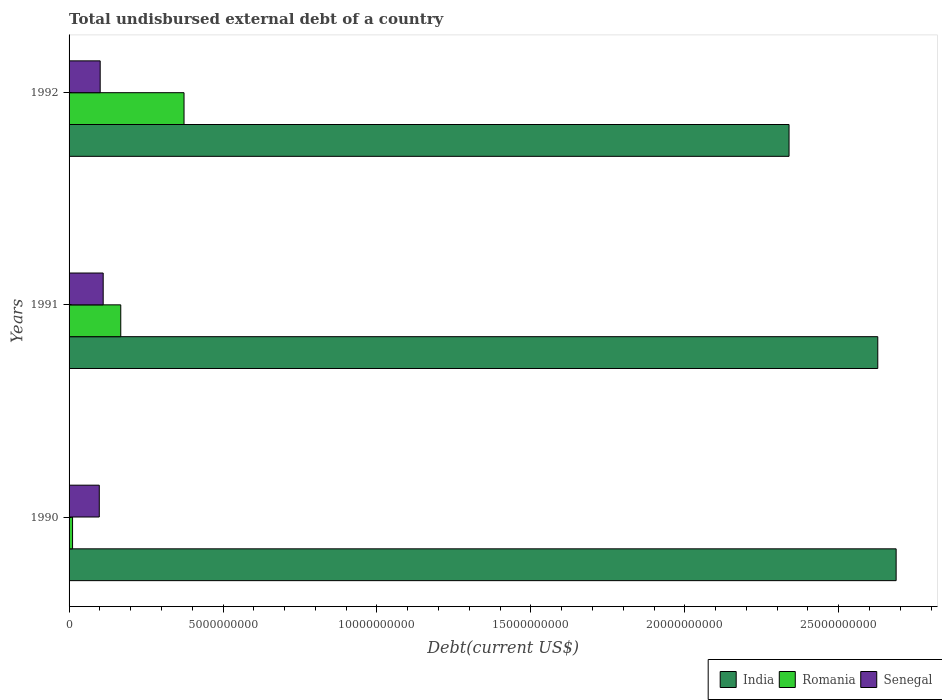How many different coloured bars are there?
Your response must be concise. 3. How many groups of bars are there?
Provide a succinct answer. 3. Are the number of bars per tick equal to the number of legend labels?
Your answer should be very brief. Yes. Are the number of bars on each tick of the Y-axis equal?
Provide a succinct answer. Yes. How many bars are there on the 3rd tick from the top?
Your response must be concise. 3. What is the label of the 3rd group of bars from the top?
Ensure brevity in your answer.  1990. What is the total undisbursed external debt in Romania in 1991?
Your answer should be very brief. 1.68e+09. Across all years, what is the maximum total undisbursed external debt in India?
Keep it short and to the point. 2.69e+1. Across all years, what is the minimum total undisbursed external debt in Romania?
Provide a short and direct response. 1.13e+08. In which year was the total undisbursed external debt in Romania maximum?
Give a very brief answer. 1992. In which year was the total undisbursed external debt in Senegal minimum?
Ensure brevity in your answer.  1990. What is the total total undisbursed external debt in Senegal in the graph?
Offer a terse response. 3.10e+09. What is the difference between the total undisbursed external debt in Romania in 1990 and that in 1991?
Offer a terse response. -1.57e+09. What is the difference between the total undisbursed external debt in Romania in 1990 and the total undisbursed external debt in Senegal in 1992?
Your answer should be very brief. -8.97e+08. What is the average total undisbursed external debt in Senegal per year?
Give a very brief answer. 1.03e+09. In the year 1991, what is the difference between the total undisbursed external debt in Senegal and total undisbursed external debt in Romania?
Offer a very short reply. -5.71e+08. What is the ratio of the total undisbursed external debt in Senegal in 1991 to that in 1992?
Ensure brevity in your answer.  1.1. Is the difference between the total undisbursed external debt in Senegal in 1990 and 1992 greater than the difference between the total undisbursed external debt in Romania in 1990 and 1992?
Provide a short and direct response. Yes. What is the difference between the highest and the second highest total undisbursed external debt in Romania?
Your answer should be very brief. 2.05e+09. What is the difference between the highest and the lowest total undisbursed external debt in India?
Offer a very short reply. 3.48e+09. In how many years, is the total undisbursed external debt in Senegal greater than the average total undisbursed external debt in Senegal taken over all years?
Ensure brevity in your answer.  1. What does the 2nd bar from the bottom in 1990 represents?
Provide a short and direct response. Romania. Is it the case that in every year, the sum of the total undisbursed external debt in India and total undisbursed external debt in Romania is greater than the total undisbursed external debt in Senegal?
Your response must be concise. Yes. How many bars are there?
Your answer should be compact. 9. Are all the bars in the graph horizontal?
Offer a terse response. Yes. What is the difference between two consecutive major ticks on the X-axis?
Your response must be concise. 5.00e+09. Where does the legend appear in the graph?
Your response must be concise. Bottom right. What is the title of the graph?
Offer a very short reply. Total undisbursed external debt of a country. What is the label or title of the X-axis?
Offer a very short reply. Debt(current US$). What is the Debt(current US$) in India in 1990?
Provide a short and direct response. 2.69e+1. What is the Debt(current US$) in Romania in 1990?
Your response must be concise. 1.13e+08. What is the Debt(current US$) in Senegal in 1990?
Your response must be concise. 9.81e+08. What is the Debt(current US$) of India in 1991?
Keep it short and to the point. 2.63e+1. What is the Debt(current US$) in Romania in 1991?
Your answer should be very brief. 1.68e+09. What is the Debt(current US$) in Senegal in 1991?
Your answer should be very brief. 1.11e+09. What is the Debt(current US$) of India in 1992?
Keep it short and to the point. 2.34e+1. What is the Debt(current US$) of Romania in 1992?
Provide a short and direct response. 3.73e+09. What is the Debt(current US$) in Senegal in 1992?
Provide a succinct answer. 1.01e+09. Across all years, what is the maximum Debt(current US$) of India?
Make the answer very short. 2.69e+1. Across all years, what is the maximum Debt(current US$) in Romania?
Ensure brevity in your answer.  3.73e+09. Across all years, what is the maximum Debt(current US$) in Senegal?
Ensure brevity in your answer.  1.11e+09. Across all years, what is the minimum Debt(current US$) in India?
Your response must be concise. 2.34e+1. Across all years, what is the minimum Debt(current US$) in Romania?
Your response must be concise. 1.13e+08. Across all years, what is the minimum Debt(current US$) in Senegal?
Make the answer very short. 9.81e+08. What is the total Debt(current US$) in India in the graph?
Give a very brief answer. 7.65e+1. What is the total Debt(current US$) in Romania in the graph?
Give a very brief answer. 5.53e+09. What is the total Debt(current US$) in Senegal in the graph?
Your response must be concise. 3.10e+09. What is the difference between the Debt(current US$) in India in 1990 and that in 1991?
Ensure brevity in your answer.  5.96e+08. What is the difference between the Debt(current US$) of Romania in 1990 and that in 1991?
Ensure brevity in your answer.  -1.57e+09. What is the difference between the Debt(current US$) in Senegal in 1990 and that in 1991?
Keep it short and to the point. -1.27e+08. What is the difference between the Debt(current US$) of India in 1990 and that in 1992?
Provide a succinct answer. 3.48e+09. What is the difference between the Debt(current US$) of Romania in 1990 and that in 1992?
Give a very brief answer. -3.62e+09. What is the difference between the Debt(current US$) of Senegal in 1990 and that in 1992?
Offer a very short reply. -2.93e+07. What is the difference between the Debt(current US$) in India in 1991 and that in 1992?
Keep it short and to the point. 2.88e+09. What is the difference between the Debt(current US$) in Romania in 1991 and that in 1992?
Your response must be concise. -2.05e+09. What is the difference between the Debt(current US$) in Senegal in 1991 and that in 1992?
Give a very brief answer. 9.74e+07. What is the difference between the Debt(current US$) of India in 1990 and the Debt(current US$) of Romania in 1991?
Your answer should be compact. 2.52e+1. What is the difference between the Debt(current US$) in India in 1990 and the Debt(current US$) in Senegal in 1991?
Offer a very short reply. 2.58e+1. What is the difference between the Debt(current US$) of Romania in 1990 and the Debt(current US$) of Senegal in 1991?
Make the answer very short. -9.95e+08. What is the difference between the Debt(current US$) in India in 1990 and the Debt(current US$) in Romania in 1992?
Your answer should be compact. 2.31e+1. What is the difference between the Debt(current US$) in India in 1990 and the Debt(current US$) in Senegal in 1992?
Your answer should be very brief. 2.59e+1. What is the difference between the Debt(current US$) of Romania in 1990 and the Debt(current US$) of Senegal in 1992?
Make the answer very short. -8.97e+08. What is the difference between the Debt(current US$) of India in 1991 and the Debt(current US$) of Romania in 1992?
Provide a succinct answer. 2.25e+1. What is the difference between the Debt(current US$) of India in 1991 and the Debt(current US$) of Senegal in 1992?
Keep it short and to the point. 2.53e+1. What is the difference between the Debt(current US$) of Romania in 1991 and the Debt(current US$) of Senegal in 1992?
Offer a very short reply. 6.69e+08. What is the average Debt(current US$) of India per year?
Give a very brief answer. 2.55e+1. What is the average Debt(current US$) of Romania per year?
Give a very brief answer. 1.84e+09. What is the average Debt(current US$) in Senegal per year?
Your answer should be compact. 1.03e+09. In the year 1990, what is the difference between the Debt(current US$) in India and Debt(current US$) in Romania?
Your answer should be compact. 2.68e+1. In the year 1990, what is the difference between the Debt(current US$) of India and Debt(current US$) of Senegal?
Ensure brevity in your answer.  2.59e+1. In the year 1990, what is the difference between the Debt(current US$) in Romania and Debt(current US$) in Senegal?
Offer a very short reply. -8.68e+08. In the year 1991, what is the difference between the Debt(current US$) in India and Debt(current US$) in Romania?
Make the answer very short. 2.46e+1. In the year 1991, what is the difference between the Debt(current US$) in India and Debt(current US$) in Senegal?
Offer a terse response. 2.52e+1. In the year 1991, what is the difference between the Debt(current US$) in Romania and Debt(current US$) in Senegal?
Give a very brief answer. 5.71e+08. In the year 1992, what is the difference between the Debt(current US$) in India and Debt(current US$) in Romania?
Offer a very short reply. 1.97e+1. In the year 1992, what is the difference between the Debt(current US$) in India and Debt(current US$) in Senegal?
Provide a succinct answer. 2.24e+1. In the year 1992, what is the difference between the Debt(current US$) of Romania and Debt(current US$) of Senegal?
Give a very brief answer. 2.72e+09. What is the ratio of the Debt(current US$) of India in 1990 to that in 1991?
Ensure brevity in your answer.  1.02. What is the ratio of the Debt(current US$) of Romania in 1990 to that in 1991?
Provide a short and direct response. 0.07. What is the ratio of the Debt(current US$) in Senegal in 1990 to that in 1991?
Your answer should be very brief. 0.89. What is the ratio of the Debt(current US$) of India in 1990 to that in 1992?
Make the answer very short. 1.15. What is the ratio of the Debt(current US$) of Romania in 1990 to that in 1992?
Offer a terse response. 0.03. What is the ratio of the Debt(current US$) in Senegal in 1990 to that in 1992?
Provide a short and direct response. 0.97. What is the ratio of the Debt(current US$) of India in 1991 to that in 1992?
Offer a very short reply. 1.12. What is the ratio of the Debt(current US$) in Romania in 1991 to that in 1992?
Give a very brief answer. 0.45. What is the ratio of the Debt(current US$) of Senegal in 1991 to that in 1992?
Provide a short and direct response. 1.1. What is the difference between the highest and the second highest Debt(current US$) in India?
Your answer should be very brief. 5.96e+08. What is the difference between the highest and the second highest Debt(current US$) in Romania?
Provide a short and direct response. 2.05e+09. What is the difference between the highest and the second highest Debt(current US$) in Senegal?
Your response must be concise. 9.74e+07. What is the difference between the highest and the lowest Debt(current US$) in India?
Make the answer very short. 3.48e+09. What is the difference between the highest and the lowest Debt(current US$) in Romania?
Your response must be concise. 3.62e+09. What is the difference between the highest and the lowest Debt(current US$) of Senegal?
Provide a succinct answer. 1.27e+08. 